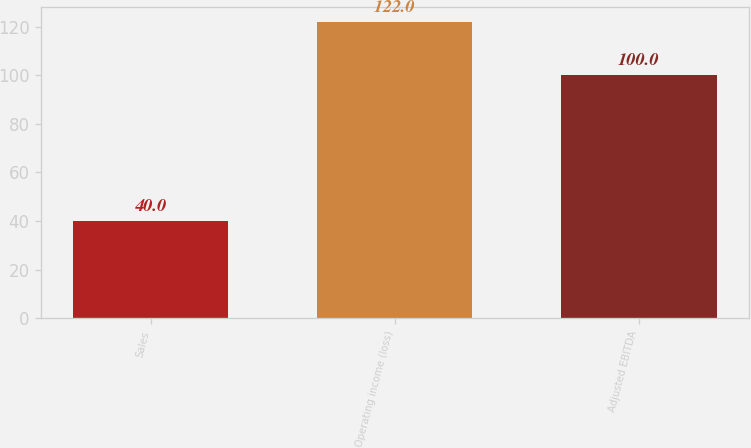Convert chart. <chart><loc_0><loc_0><loc_500><loc_500><bar_chart><fcel>Sales<fcel>Operating income (loss)<fcel>Adjusted EBITDA<nl><fcel>40<fcel>122<fcel>100<nl></chart> 